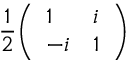<formula> <loc_0><loc_0><loc_500><loc_500>{ \frac { 1 } { 2 } } { \left ( \begin{array} { l l } { 1 } & { i } \\ { - i } & { 1 } \end{array} \right ) }</formula> 